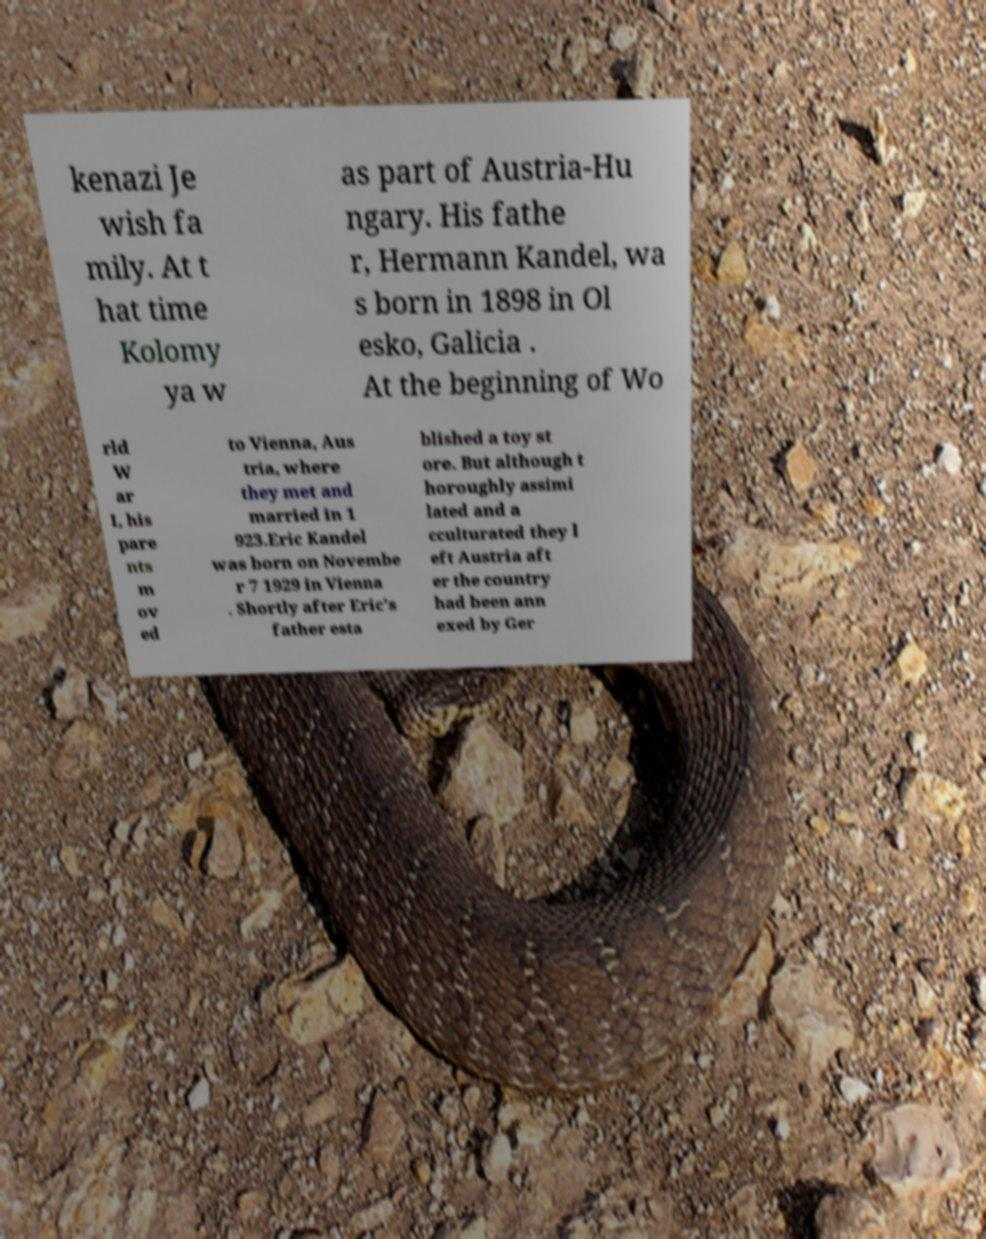Can you read and provide the text displayed in the image?This photo seems to have some interesting text. Can you extract and type it out for me? kenazi Je wish fa mily. At t hat time Kolomy ya w as part of Austria-Hu ngary. His fathe r, Hermann Kandel, wa s born in 1898 in Ol esko, Galicia . At the beginning of Wo rld W ar I, his pare nts m ov ed to Vienna, Aus tria, where they met and married in 1 923.Eric Kandel was born on Novembe r 7 1929 in Vienna . Shortly after Eric's father esta blished a toy st ore. But although t horoughly assimi lated and a cculturated they l eft Austria aft er the country had been ann exed by Ger 